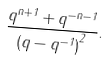Convert formula to latex. <formula><loc_0><loc_0><loc_500><loc_500>\frac { q ^ { n + 1 } + q ^ { - n - 1 } } { { ( q - q ^ { - 1 } ) } ^ { 2 } } .</formula> 